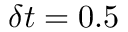Convert formula to latex. <formula><loc_0><loc_0><loc_500><loc_500>\delta t = 0 . 5</formula> 